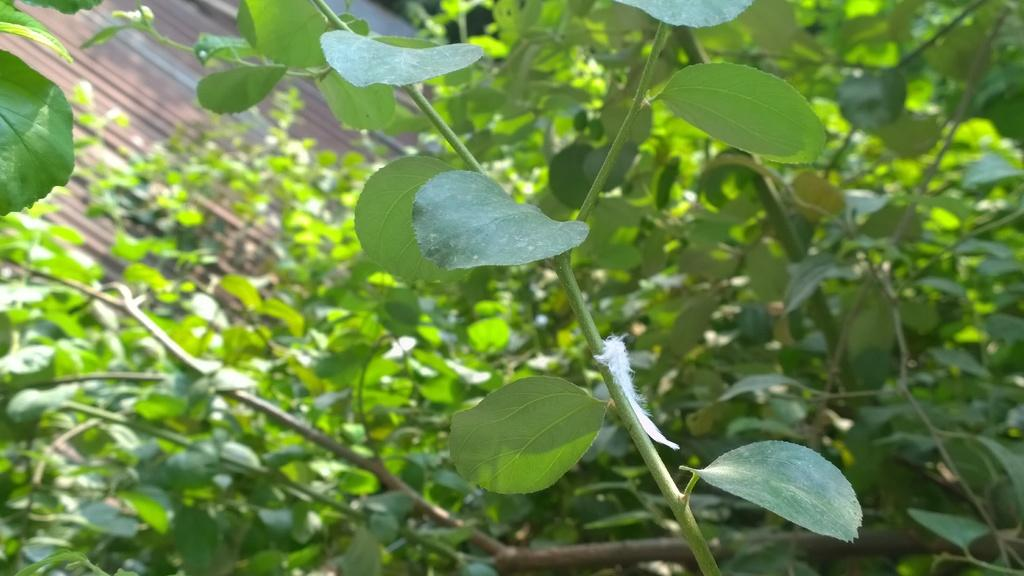What type of vegetation can be seen in the image? There are trees in the image. Can you describe the background of the image? There is an object visible in the background of the image. What type of gun is being used by the students in the image? There is no gun or students present in the image; it only features trees and an object in the background. 